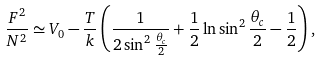Convert formula to latex. <formula><loc_0><loc_0><loc_500><loc_500>\frac { F ^ { 2 } } { N ^ { 2 } } \simeq V _ { 0 } - \frac { T } { k } \left ( \frac { 1 } { 2 \sin ^ { 2 } \frac { \theta _ { c } } { 2 } } + \frac { 1 } { 2 } \ln \sin ^ { 2 } \frac { \theta _ { c } } { 2 } - \frac { 1 } { 2 } \right ) ,</formula> 